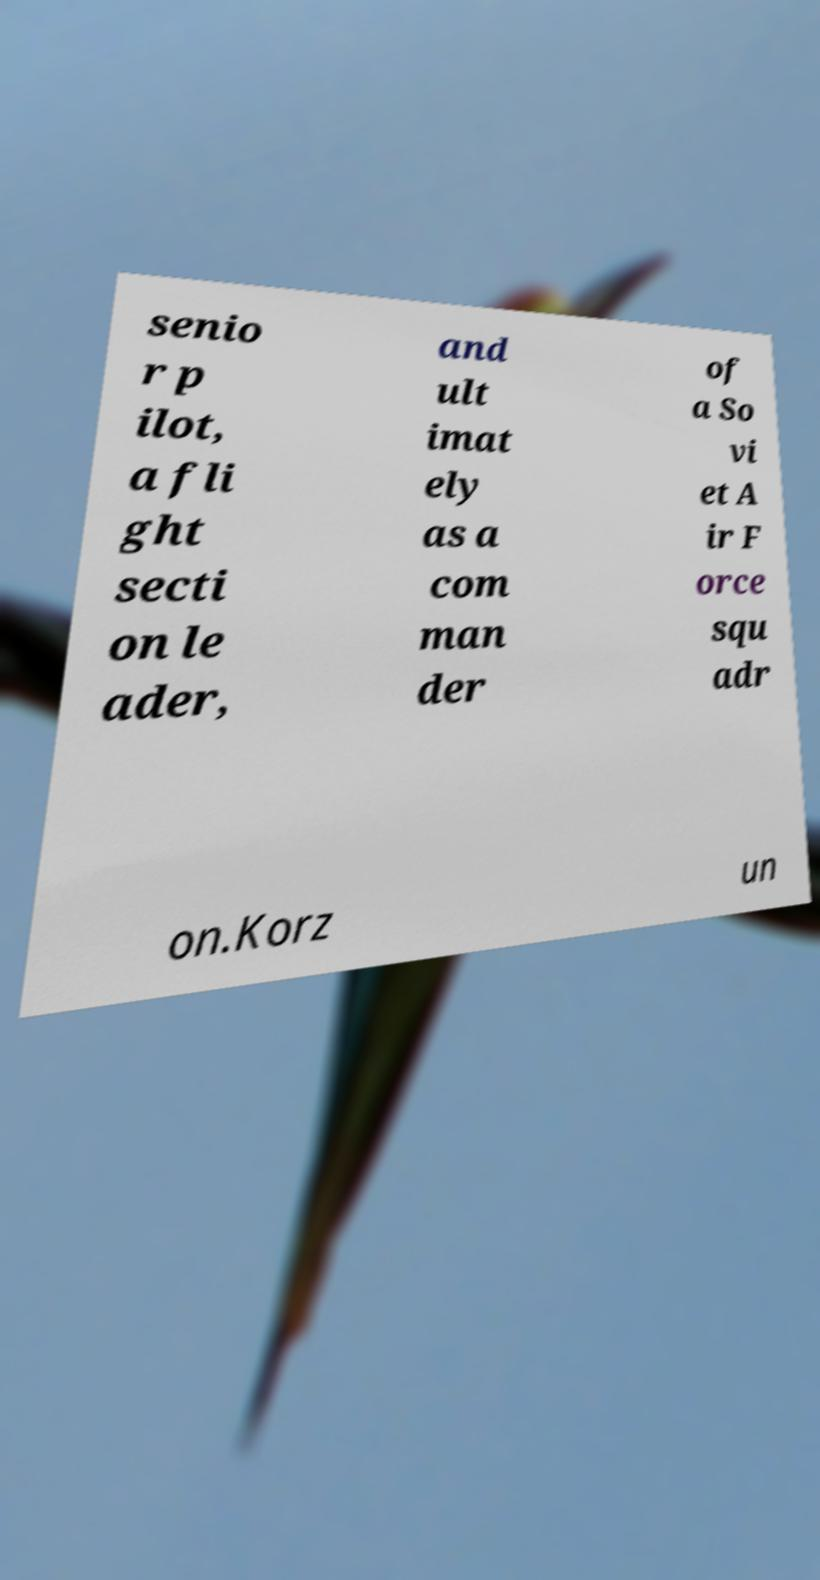Please read and relay the text visible in this image. What does it say? senio r p ilot, a fli ght secti on le ader, and ult imat ely as a com man der of a So vi et A ir F orce squ adr on.Korz un 